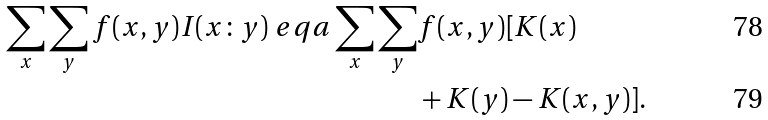<formula> <loc_0><loc_0><loc_500><loc_500>\sum _ { x } \sum _ { y } f ( x , y ) I ( x \colon y ) \ e q a \sum _ { x } \sum _ { y } & f ( x , y ) [ K ( x ) \\ & + K ( y ) - K ( x , y ) ] .</formula> 